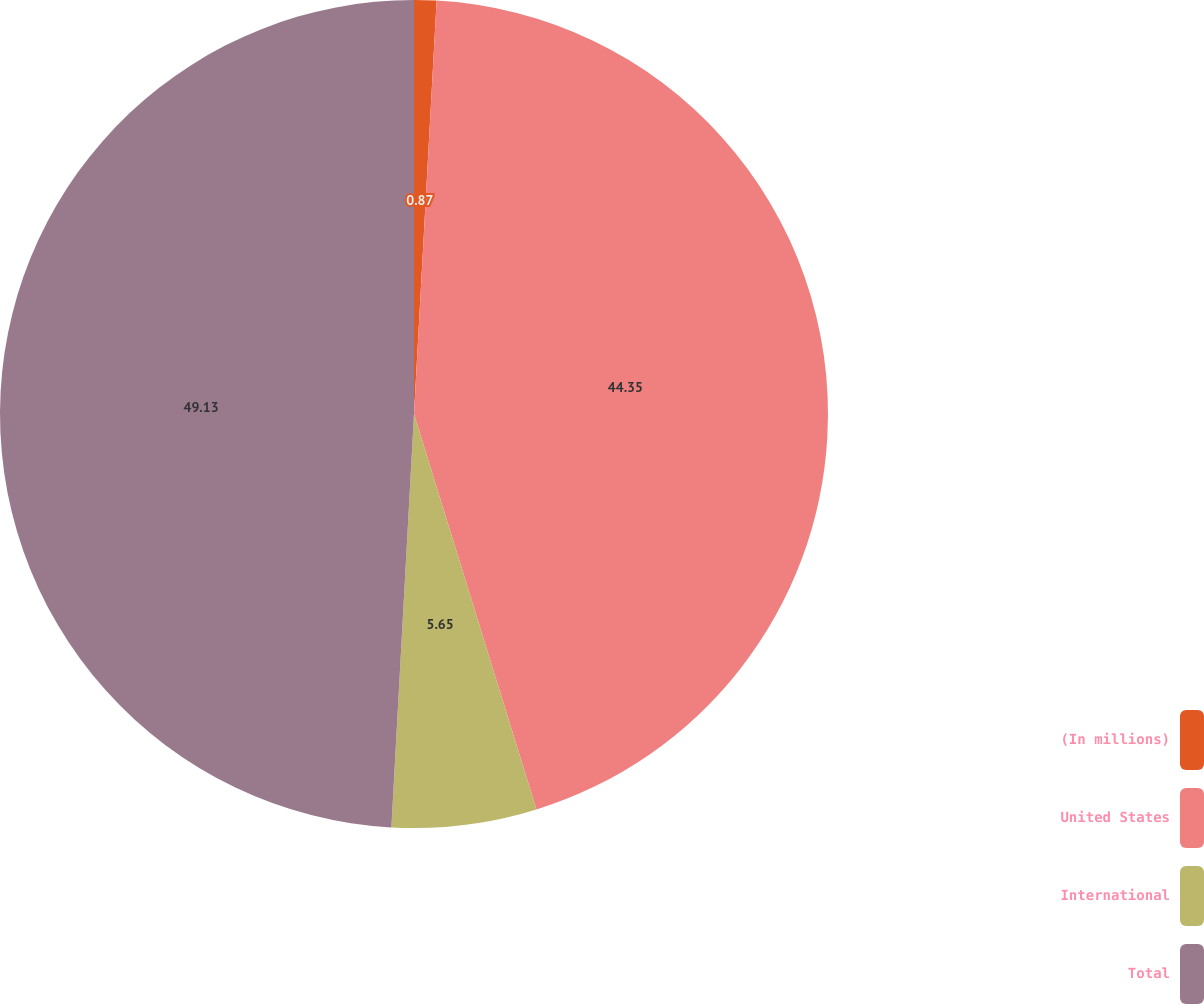Convert chart. <chart><loc_0><loc_0><loc_500><loc_500><pie_chart><fcel>(In millions)<fcel>United States<fcel>International<fcel>Total<nl><fcel>0.87%<fcel>44.35%<fcel>5.65%<fcel>49.13%<nl></chart> 